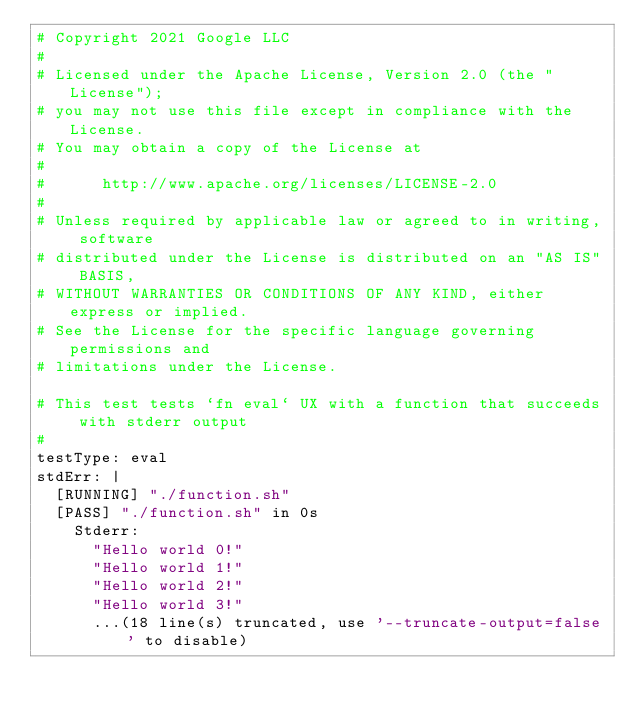Convert code to text. <code><loc_0><loc_0><loc_500><loc_500><_YAML_># Copyright 2021 Google LLC
#
# Licensed under the Apache License, Version 2.0 (the "License");
# you may not use this file except in compliance with the License.
# You may obtain a copy of the License at
#
#      http://www.apache.org/licenses/LICENSE-2.0
#
# Unless required by applicable law or agreed to in writing, software
# distributed under the License is distributed on an "AS IS" BASIS,
# WITHOUT WARRANTIES OR CONDITIONS OF ANY KIND, either express or implied.
# See the License for the specific language governing permissions and
# limitations under the License.

# This test tests `fn eval` UX with a function that succeeds with stderr output
#
testType: eval
stdErr: |
  [RUNNING] "./function.sh"
  [PASS] "./function.sh" in 0s
    Stderr:
      "Hello world 0!"
      "Hello world 1!"
      "Hello world 2!"
      "Hello world 3!"
      ...(18 line(s) truncated, use '--truncate-output=false' to disable)
</code> 